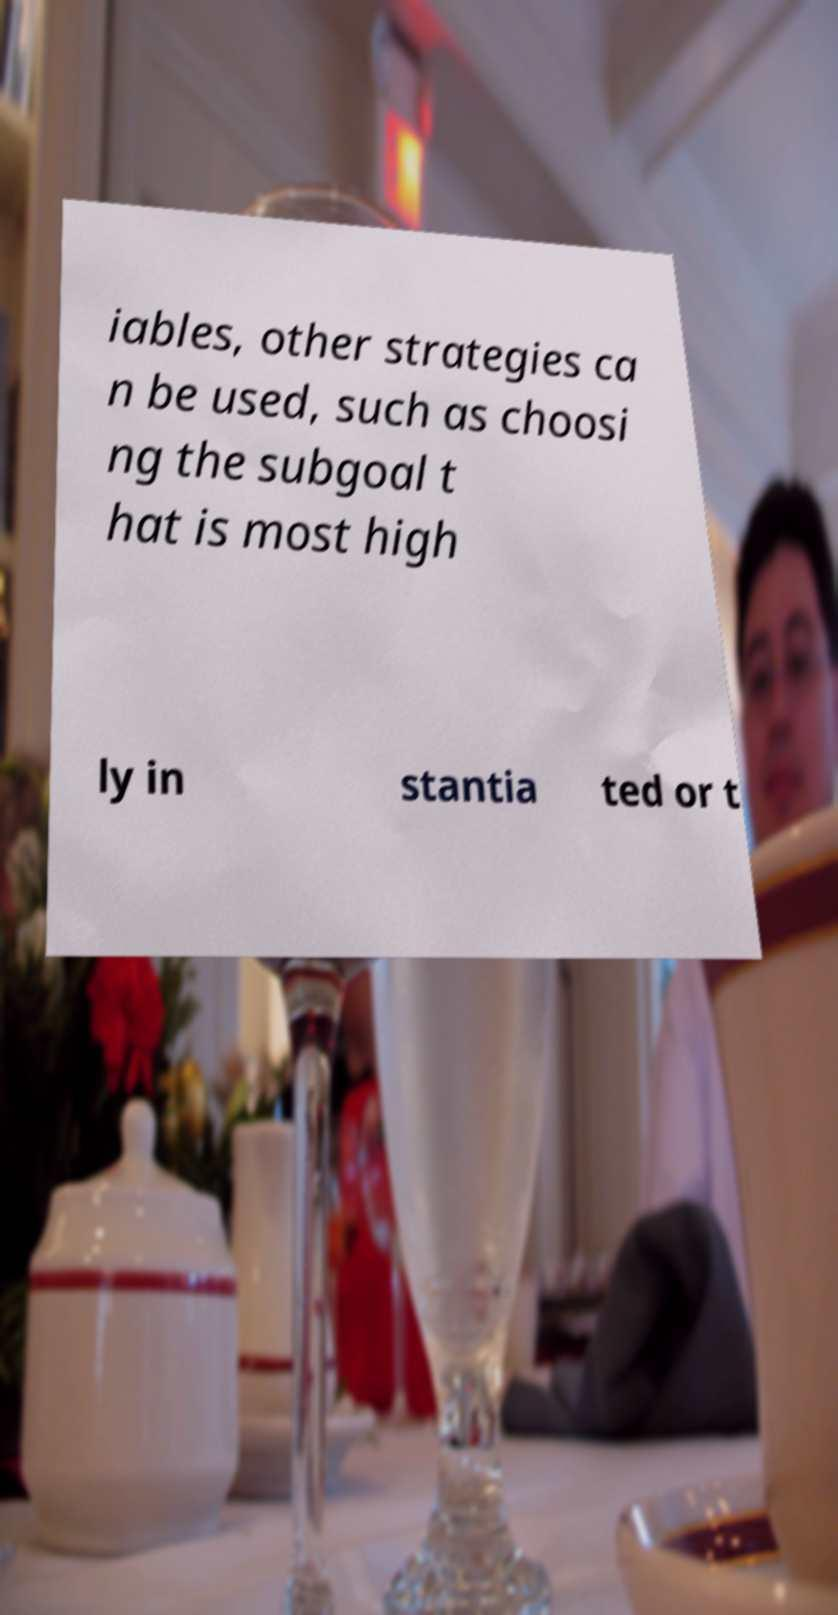Could you extract and type out the text from this image? iables, other strategies ca n be used, such as choosi ng the subgoal t hat is most high ly in stantia ted or t 